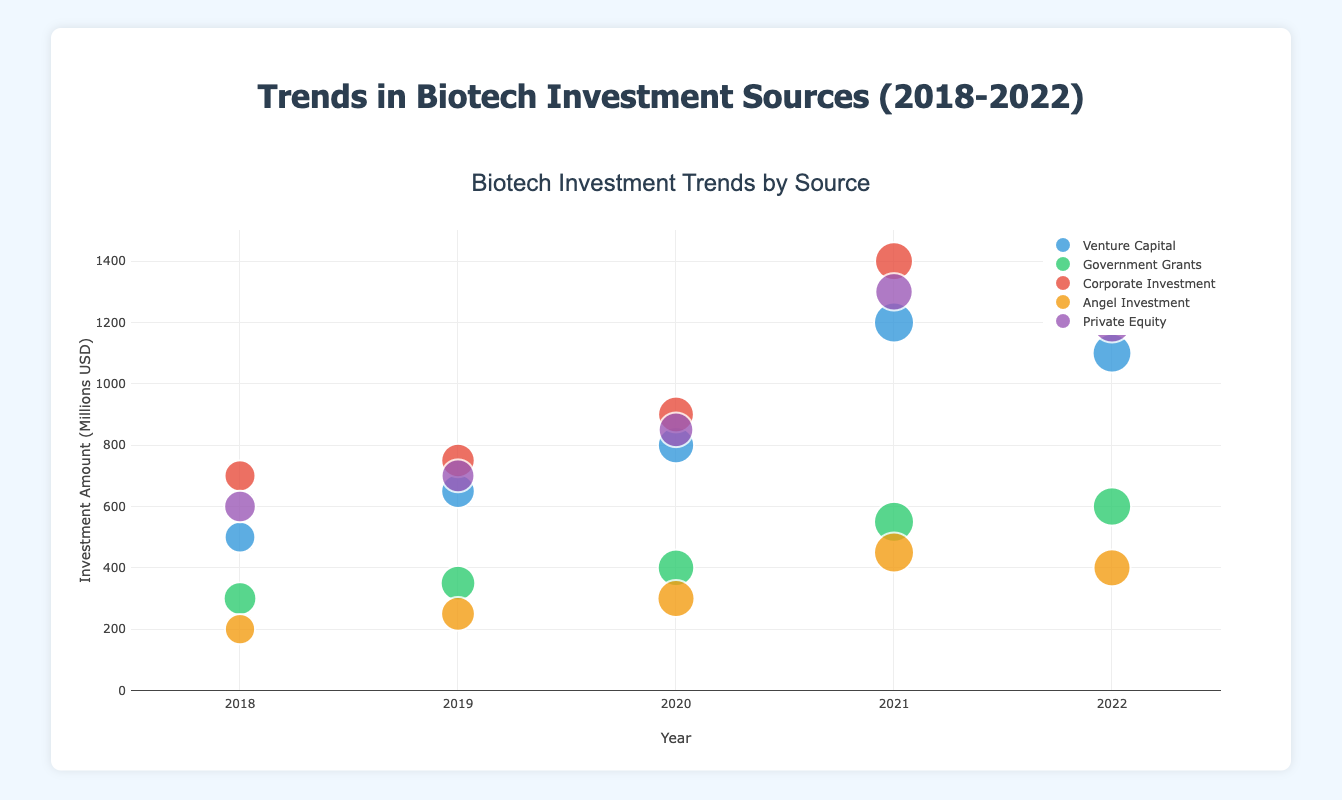What is the trend for Venture Capital investments from 2018 to 2022? The plot shows an upward trend in the amount invested by Venture Capital from 2018 to 2021, peaking in 2021 at $1200 million, and then a slight decrease in 2022 to $1100 million
Answer: Upward trend with a peak in 2021 Which investment source saw the highest amount in 2021? The plot shows that in 2021 Corporate Investment had the highest amount at $1400 million, which is higher than any other investment source that year
Answer: Corporate Investment How many entities received Government Grants in 2020? By hovering over the Government Grants bubble for 2020, we see that 50 entities received grants
Answer: 50 Comparing Angel Investment and Private Equity in 2022, which had more entities? The plot shows Angel Investment had 30 entities, while Private Equity had 40 entities
Answer: Private Equity What is the general shape of the trajectory for Corporate Investment from 2018 to 2022? The data for Corporate Investment shows an increasing trend from 2018 to 2021, peaking in 2021 and then slightly decreasing in 2022
Answer: Increasing trend, peak in 2021, slight decrease in 2022 What is the difference in the number of entities between Venture Capital and Government Grants in 2021? In 2021, Venture Capital had 85 entities, and Government Grants had 60 entities. The difference is 85 - 60 = 25
Answer: 25 By how much did the amount of Private Equity change from 2018 to 2022? In 2018, the amount was $600 million, and in 2022, it was $1200 million, indicating an increase of $1200 - $600 = $600 million
Answer: $600 million Which year had the highest number of entities for Venture Capital investments? By reviewing the Venture Capital data, 2021 shows the highest number of entities with 85
Answer: 2021 What is the largest bubble on the chart? The size of the bubbles is proportionate to the number of entities. The largest bubble belongs to Corporate Investment in 2021 with 45 entities
Answer: Corporate Investment in 2021 